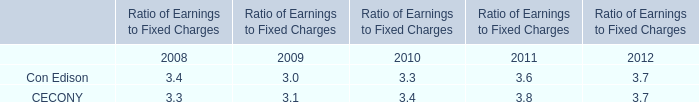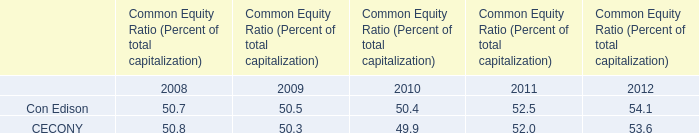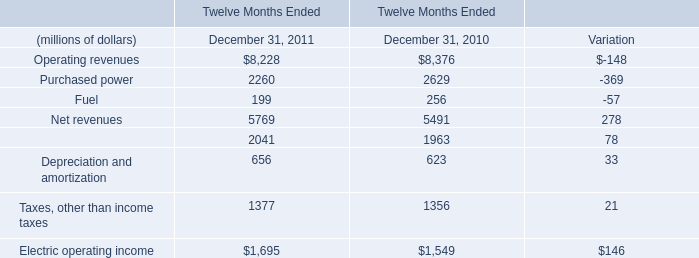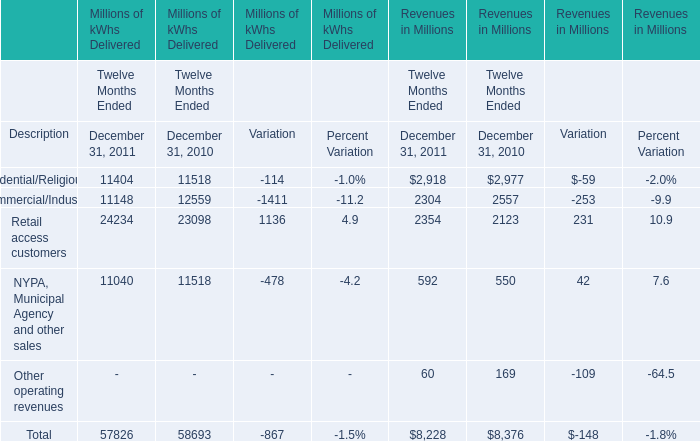What is the difference between Operations and maintenance and Operating revenues in 2011? (in million) 
Computations: (8228 - 2041)
Answer: 6187.0. 